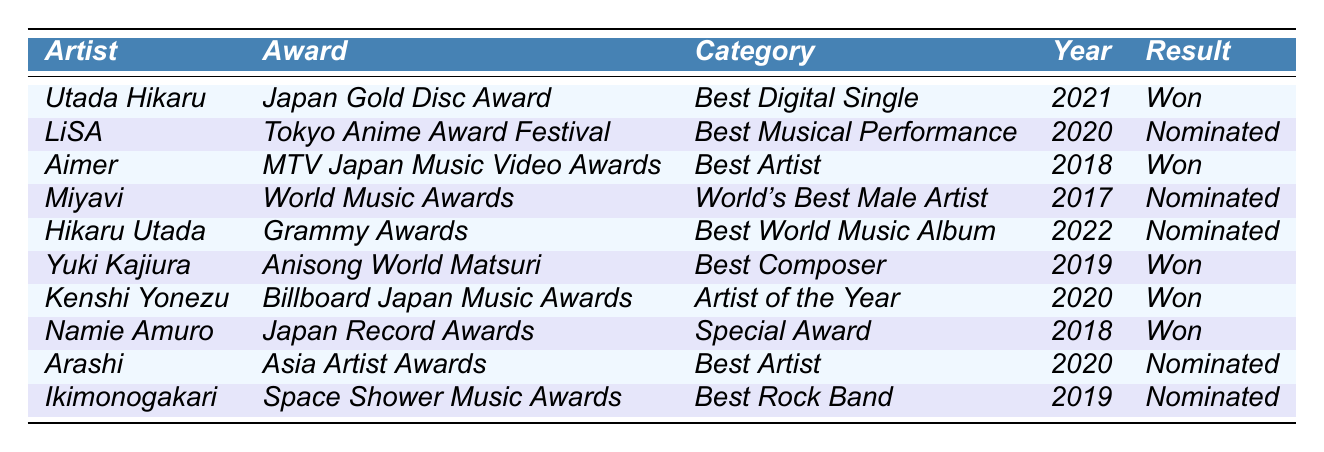What award did Utada Hikaru win in 2021? According to the table, Utada Hikaru won the Japan Gold Disc Award for Best Digital Single in 2021.
Answer: Japan Gold Disc Award How many awards did Kenshi Yonezu win in 2020? The table shows that Kenshi Yonezu won the Billboard Japan Music Awards for Artist of the Year in 2020, and there is no mention of any other awards for him that year, so he won one award.
Answer: 1 Was Aimer nominated for any awards in the past decade? The table shows that Aimer won the MTV Japan Music Video Award for Best Artist in 2018. It does not indicate any nominations, so the answer is no.
Answer: No Which artist received a nomination at the Grammy Awards? The table indicates that Hikaru Utada was nominated for the Grammy Awards in 2022 under the category of Best World Music Album.
Answer: Hikaru Utada How many artists won awards in 2018? Reviewing the table, Aimer, Namie Amuro, and Hikaru Utada received awards in 2018. Thus, there are three artists who won awards that year.
Answer: 3 What is the total number of nominations listed in the table? Scanning the table, there are three nominations: for LiSA in 2020, Miyavi in 2017, and Arashi in 2020, alongside three additional nominations for Hikaru Utada, Ikimonogakari, and Kenji Yonezu in previous years. Therefore, the total number of nominations is 5.
Answer: 5 Which year had the most nominations listed in the table? The year 2020 had three nominations: LiSA, Arashi, and Kenshi Yonezu. Thus, it has the most nominations compared to other years.
Answer: 2020 Did any artist win multiple awards in the past decade? The table does not show any artist winning multiple awards; each listed artist has either won one award or has been nominated.
Answer: No What is the difference in the number of wins between Utada Hikaru and Aimer? Utada Hikaru won one award (2021) and Aimer also won one award (2018), which means the difference in the number of wins is 0.
Answer: 0 Which artist has the highest recognition among the mentioned awards? By considering the Grammy Awards and the World Music Awards as more prestigious, Hikaru Utada has nominations in these notable awards compared to others. Thus, she has the highest recognition.
Answer: Hikaru Utada 